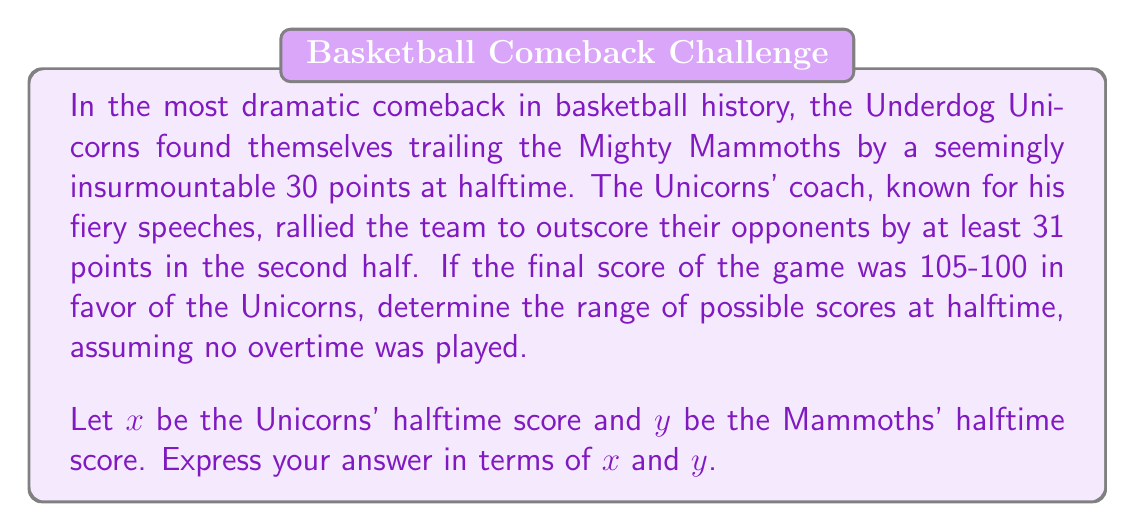What is the answer to this math problem? Let's break this down step by step:

1) At halftime, the Mammoths were leading by 30 points. We can express this as:
   $y = x + 30$

2) The final score was 105-100 in favor of the Unicorns. This means:
   $105 - x = $ Unicorns' second half score
   $100 - y = $ Mammoths' second half score

3) The Unicorns outscored the Mammoths by at least 31 points in the second half:
   $(105 - x) - (100 - y) \geq 31$

4) Simplifying the inequality in step 3:
   $105 - x - 100 + y \geq 31$
   $y - x \geq 26$

5) Substituting $y = x + 30$ from step 1:
   $(x + 30) - x \geq 26$
   $30 \geq 26$ (This is always true, confirming our setup)

6) Now, we need to find the range for $x$:
   The minimum value for $x$ is when the Unicorns scored 0 in the first half:
   $x_{min} = 0$

   The maximum value for $x$ is when the Mammoths scored all 100 of their points in the first half:
   $y_{max} = 100$
   $x_{max} = y_{max} - 30 = 70$

Therefore, $0 \leq x \leq 70$

And since $y = x + 30$, we have $30 \leq y \leq 100$
Answer: The range of possible halftime scores is:
$0 \leq x \leq 70$ for the Unicorns
$30 \leq y \leq 100$ for the Mammoths
where $x$ and $y$ are the halftime scores of the Unicorns and Mammoths respectively, and $y = x + 30$. 